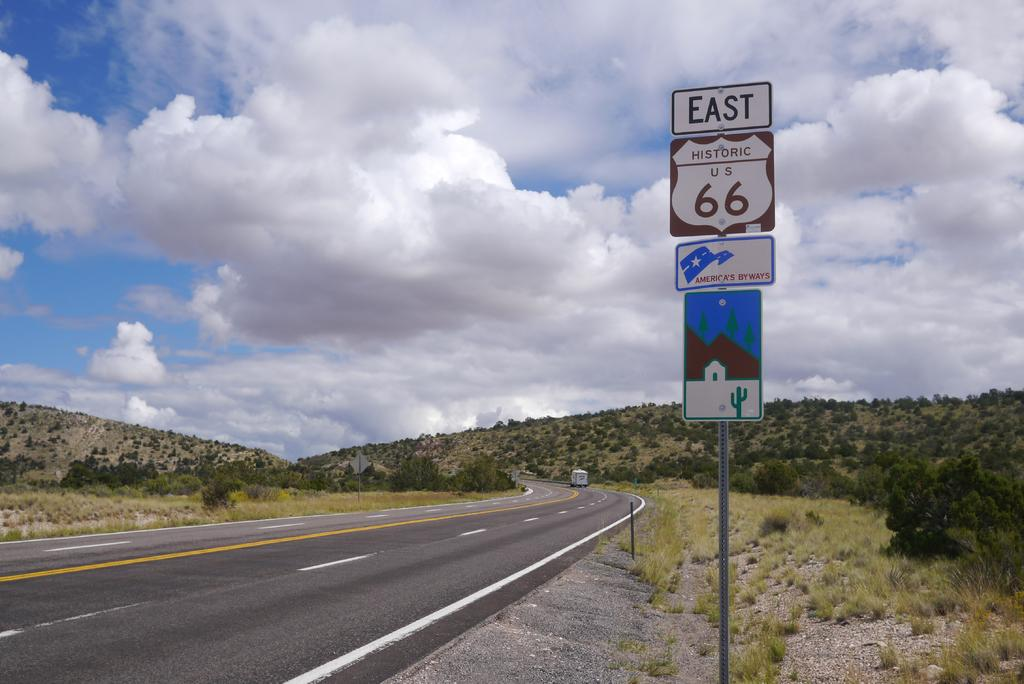<image>
Describe the image concisely. A nearly empty road with a sign on the  right reading East 66. 